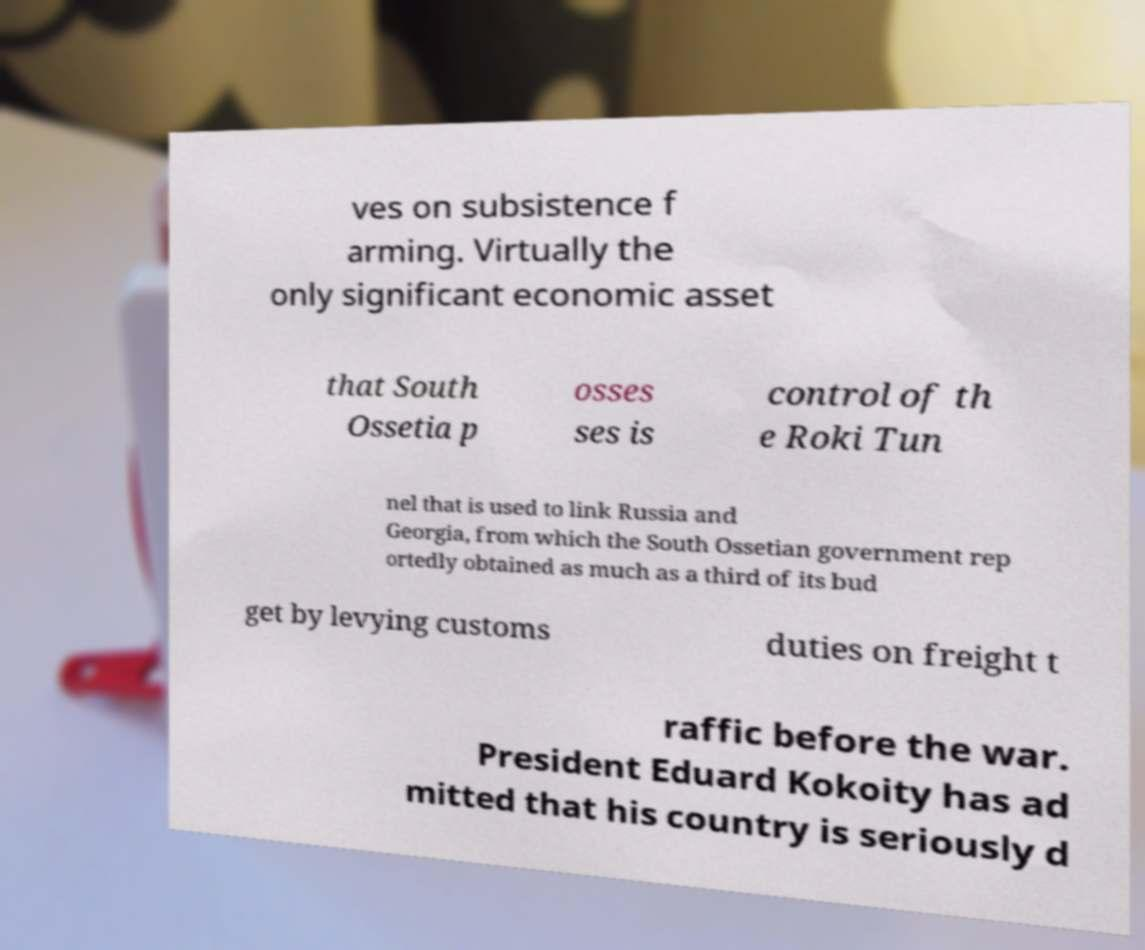Please identify and transcribe the text found in this image. ves on subsistence f arming. Virtually the only significant economic asset that South Ossetia p osses ses is control of th e Roki Tun nel that is used to link Russia and Georgia, from which the South Ossetian government rep ortedly obtained as much as a third of its bud get by levying customs duties on freight t raffic before the war. President Eduard Kokoity has ad mitted that his country is seriously d 